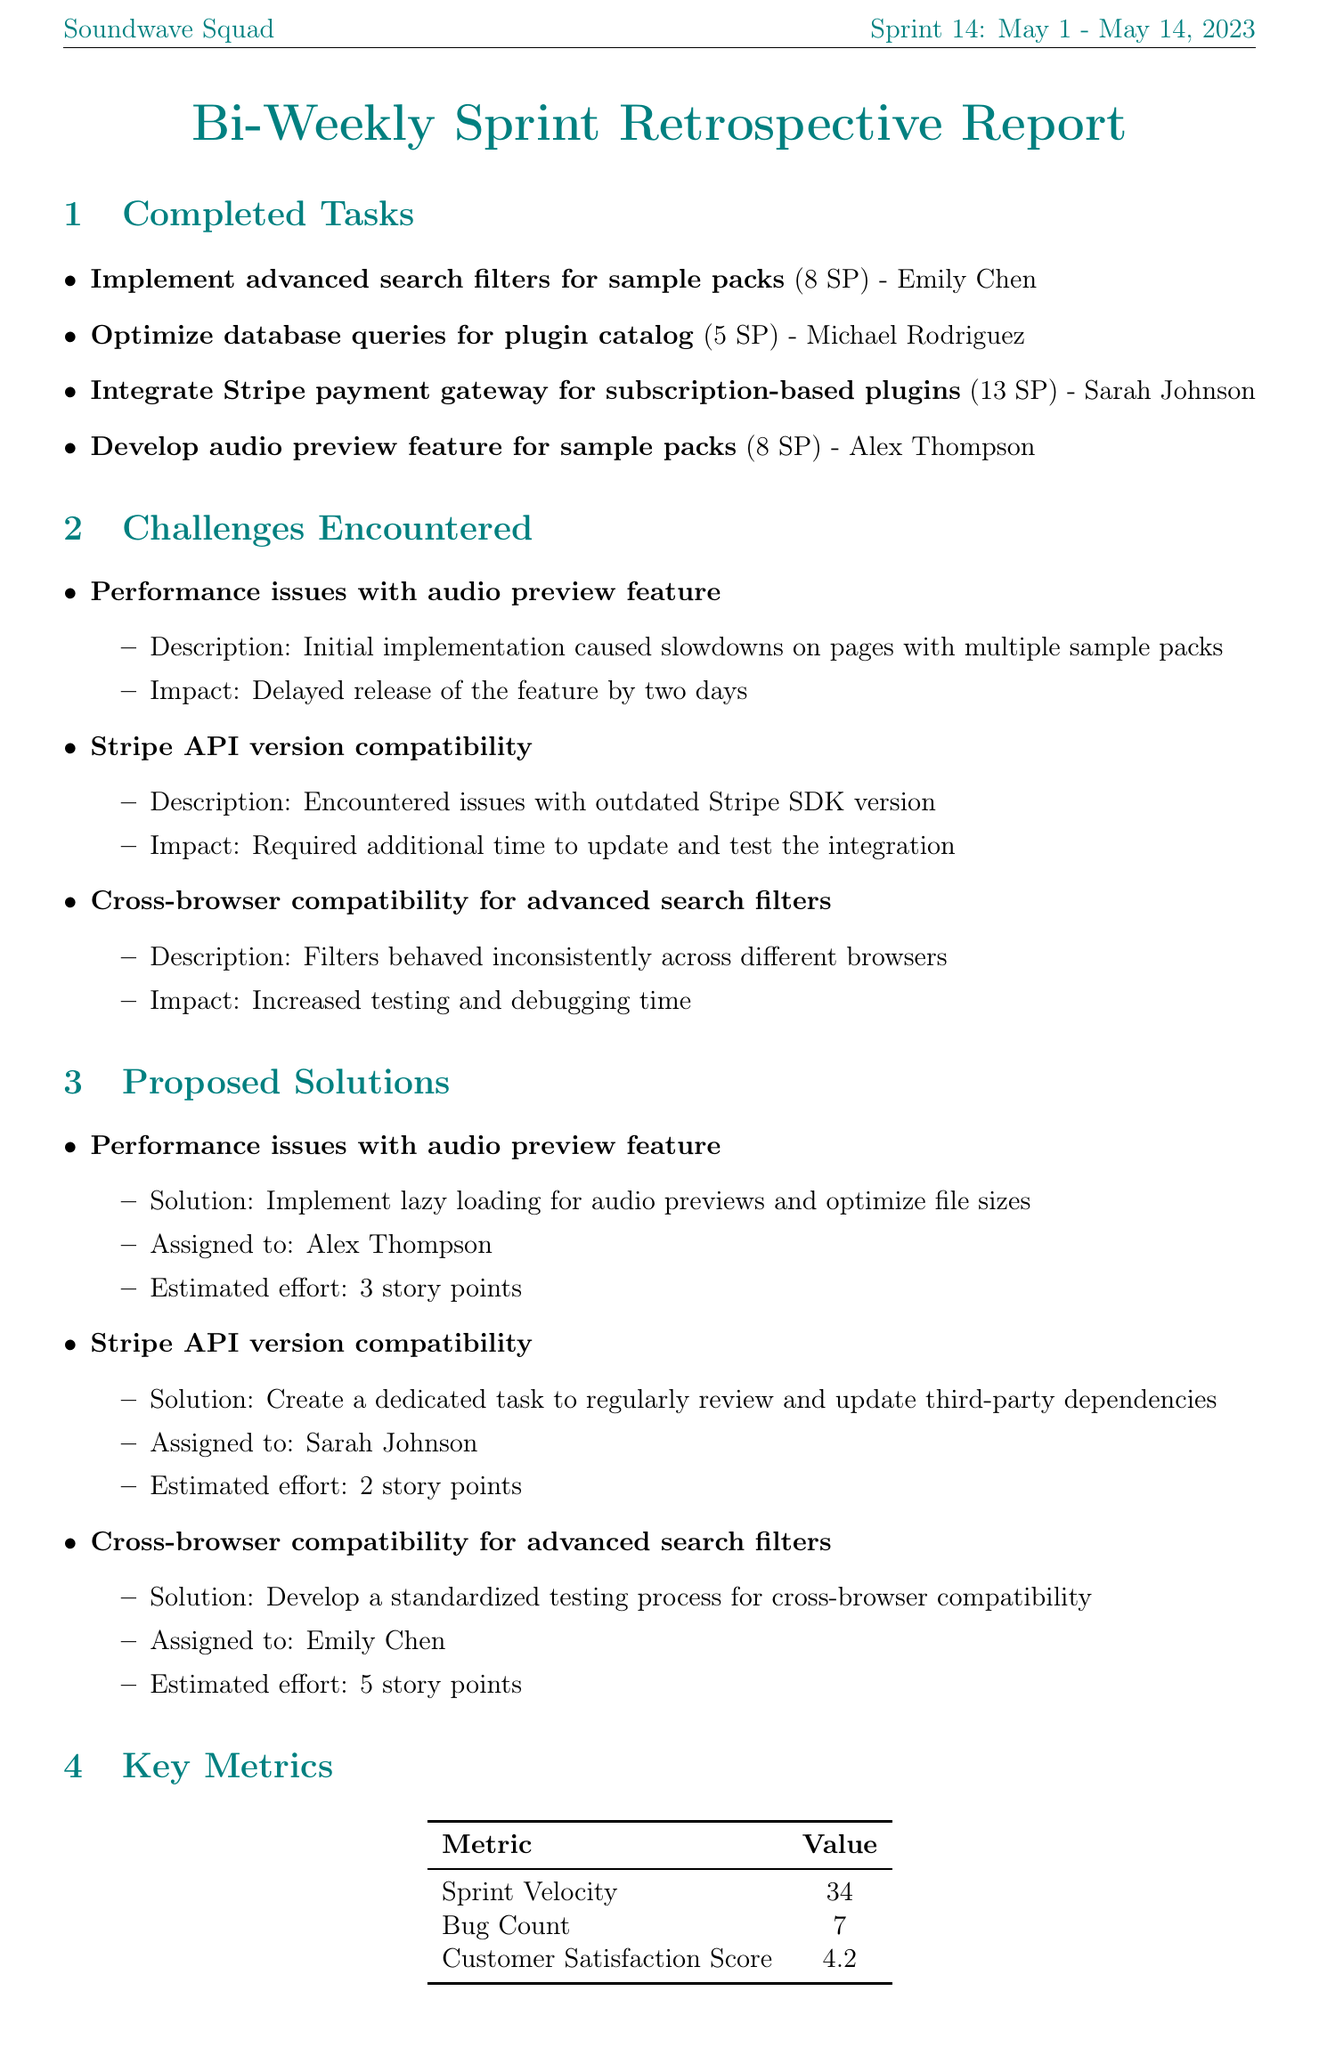What is the sprint number? The sprint number is highlighted in the sprint details section of the document as Sprint 14.
Answer: Sprint 14 Who assigned to the task of integrating the Stripe payment gateway? The name of the person responsible for the Stripe payment gateway task is mentioned in the completed tasks section under the assigned name.
Answer: Sarah Johnson What was the customer satisfaction score? The customer satisfaction score is listed under the key metrics section of the document.
Answer: 4.2 What was the impact of the performance issues with the audio preview feature? The impact of the encountered challenge related to the audio preview feature is described in detail under challenges encountered.
Answer: Delayed release of the feature by two days How many story points were assigned to optimizing database queries for the plugin catalog? The number of story points for the task of optimizing database queries is indicated in the completed tasks section.
Answer: 5 What is one of the next sprint goals? The next sprint goals are listed and each represented in a bullet point format within their section.
Answer: Implement user-generated playlists for sample packs Who received kudos for improving database query performance? The team member recognized for their achievement is noted in the team kudos section of the document.
Answer: Michael Rodriguez What solution was proposed for cross-browser compatibility issues? The solution to the challenge is specifically stated under the proposed solutions section, including assigned individual and estimated effort.
Answer: Develop a standardized testing process for cross-browser compatibility 